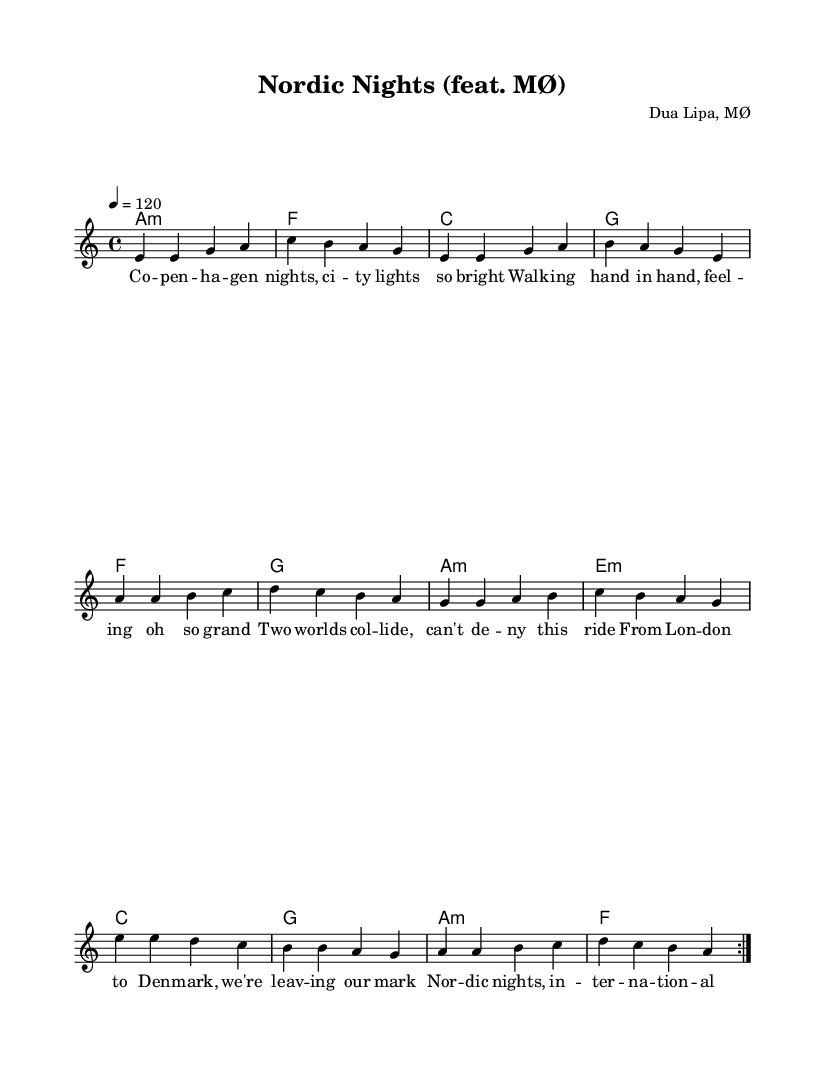What is the key signature of this music? The key signature is A minor, which has no sharps or flats, indicated by the absence of any sharp or flat symbols at the beginning of the staff.
Answer: A minor What is the time signature of this music? The time signature is 4/4, which is shown at the beginning of the staff, indicating there are four beats per measure and the quarter note gets one beat.
Answer: 4/4 What is the tempo marking for this music? The tempo marking is 120 BPM, indicated by the tempo notation "4 = 120" at the start, meaning the quarter note should be played at 120 beats per minute.
Answer: 120 How many measures are there in the repeat section? There are 8 measures in the repeat section, as indicated by the repeated volte that encapsulates two sets of 4 measures, totaling 8.
Answer: 8 What are the featured artists of the piece? The featured artists are Dua Lipa and MØ, which can be inferred from the header stating their names as composers, suggesting their collaboration on the piece.
Answer: Dua Lipa, MØ What musical form does this piece seem to resemble? The piece resembles a pop song structure, which often features a verse-chorus format. The use of repeated sections and relatable lyrics further reinforces this classification.
Answer: Pop song structure What lyric theme is presented in the song? The lyric theme presents a narrative of connectivity and cultural exchange, as seen in the lines describing Copenhagen nights and the blend of Danish and British influences.
Answer: Connectivity and cultural exchange 